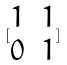Convert formula to latex. <formula><loc_0><loc_0><loc_500><loc_500>[ \begin{matrix} 1 & 1 \\ 0 & 1 \end{matrix} ]</formula> 